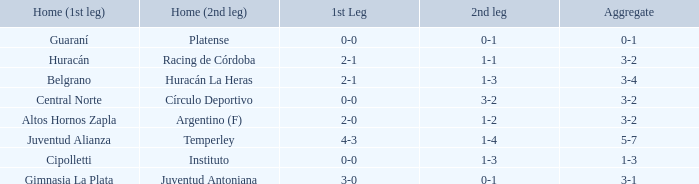Which team had their first leg at home and finished with a total score of 3-4? Belgrano. 